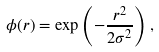<formula> <loc_0><loc_0><loc_500><loc_500>\phi ( r ) = \exp \left ( - \frac { r ^ { 2 } } { 2 \sigma ^ { 2 } } \right ) ,</formula> 